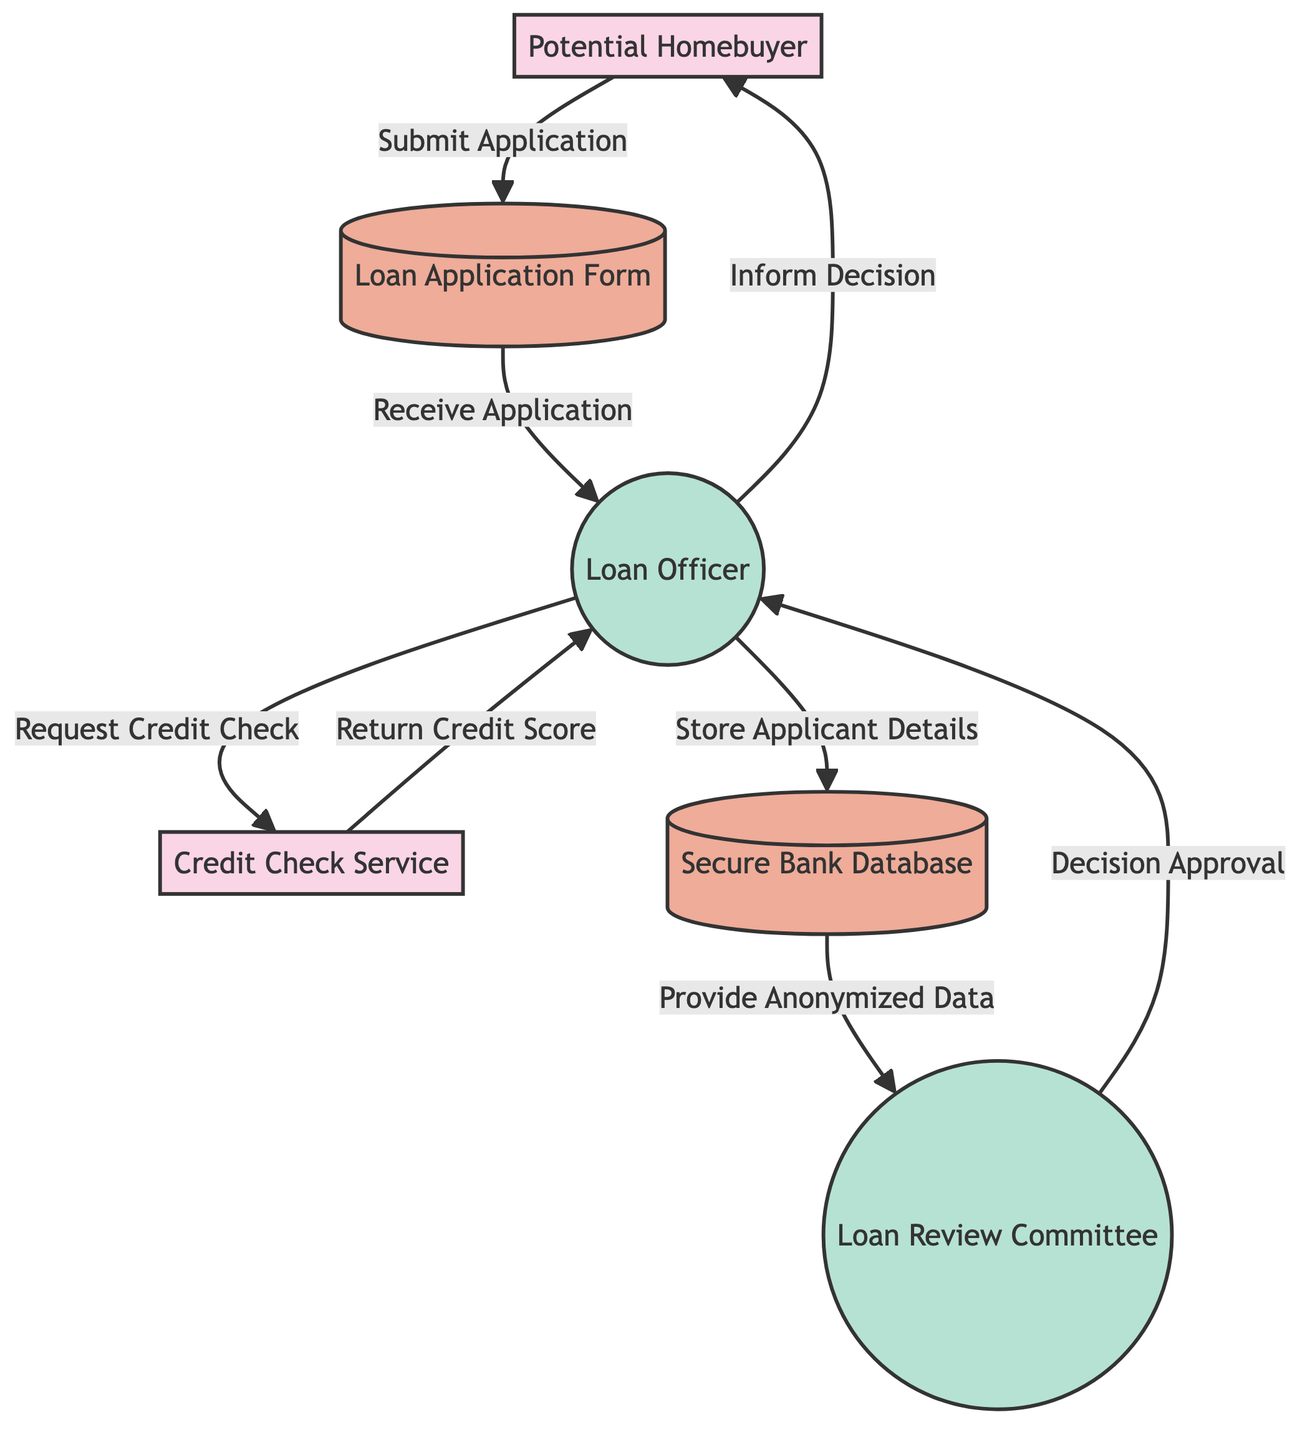What is the first step in the home loan application process? The first step in the process is the potential homebuyer submitting the loan application form. This is indicated by the arrow that flows from the "Potential Homebuyer" to the "Loan Application Form."
Answer: Submit Application How many processes are present in the diagram? To determine the number of processes, we can count the items categorized as "Process" in the diagram. There are three processes: "Loan Officer," "Loan Review Committee," and the "Secure Bank Database."
Answer: Three What does the loan officer do after receiving the application? After receiving the application, the loan officer requests a credit check from the credit check service. This is represented by the arrow going from "Loan Officer" to "Credit Check Service," labeled "Request Credit Check."
Answer: Request Credit Check Which entity returns the credit score? The entity that returns the credit score is the Credit Check Service. This can be found by following the flow from the "Credit Check Service" back to the "Loan Officer," specifically labeled as "Return Credit Score."
Answer: Credit Check Service What is stored in the secure bank database? In the secure bank database, the applicant's details are stored. This is indicated by the flow from the "Loan Officer" to the "Secure Bank Database," which is labeled "Store Applicant Details."
Answer: Applicant Details What data does the secure bank database provide to the loan review committee? The secure bank database provides anonymized data to the loan review committee for decision-making, as shown by the arrow from "Secure Bank Database" to "Loan Review Committee," labeled "Provide Anonymized Data."
Answer: Anonymized Data How does the loan officer inform the potential homebuyer of the loan decision? The loan officer informs the potential homebuyer of the loan decision by sending a result back to them, represented by the arrow from "Loan Officer" to "Potential Homebuyer," labeled "Inform Decision."
Answer: Inform Decision What type of data does the loan review committee use for making decisions? The loan review committee uses anonymized data to make their decision, which is shown in the flow from the "Secure Bank Database" to the "Loan Review Committee," labeled "Provide Anonymized Data."
Answer: Anonymized Data 